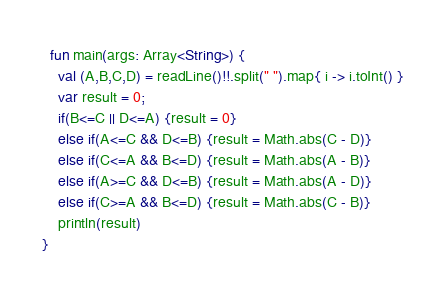<code> <loc_0><loc_0><loc_500><loc_500><_Kotlin_>  fun main(args: Array<String>) {
    val (A,B,C,D) = readLine()!!.split(" ").map{ i -> i.toInt() }
    var result = 0;
    if(B<=C || D<=A) {result = 0}
    else if(A<=C && D<=B) {result = Math.abs(C - D)} 
    else if(C<=A && B<=D) {result = Math.abs(A - B)}
    else if(A>=C && D<=B) {result = Math.abs(A - D)} 
    else if(C>=A && B<=D) {result = Math.abs(C - B)} 
    println(result)
}</code> 